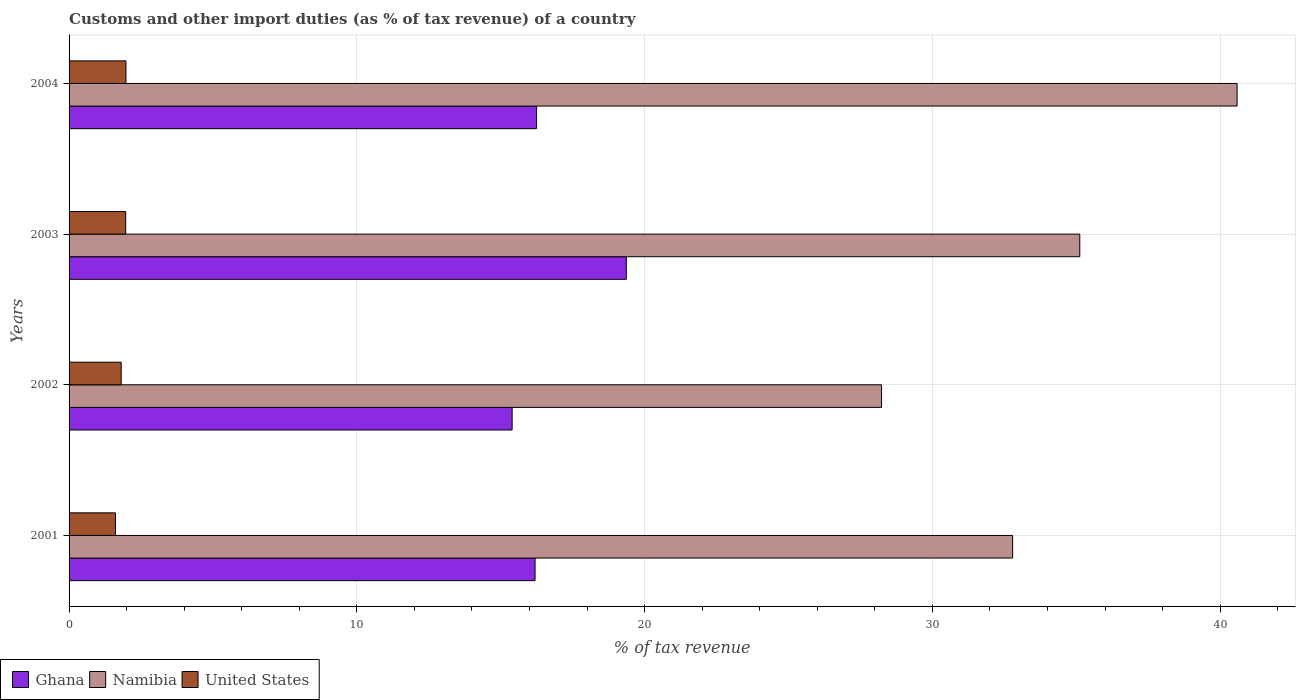How many groups of bars are there?
Provide a succinct answer. 4. Are the number of bars on each tick of the Y-axis equal?
Keep it short and to the point. Yes. How many bars are there on the 4th tick from the top?
Your answer should be very brief. 3. How many bars are there on the 1st tick from the bottom?
Your response must be concise. 3. What is the label of the 2nd group of bars from the top?
Offer a terse response. 2003. In how many cases, is the number of bars for a given year not equal to the number of legend labels?
Your response must be concise. 0. What is the percentage of tax revenue from customs in Ghana in 2004?
Provide a short and direct response. 16.25. Across all years, what is the maximum percentage of tax revenue from customs in Ghana?
Keep it short and to the point. 19.36. Across all years, what is the minimum percentage of tax revenue from customs in Ghana?
Provide a succinct answer. 15.4. In which year was the percentage of tax revenue from customs in United States minimum?
Make the answer very short. 2001. What is the total percentage of tax revenue from customs in Ghana in the graph?
Provide a short and direct response. 67.2. What is the difference between the percentage of tax revenue from customs in Namibia in 2001 and that in 2002?
Give a very brief answer. 4.55. What is the difference between the percentage of tax revenue from customs in United States in 2003 and the percentage of tax revenue from customs in Namibia in 2002?
Give a very brief answer. -26.27. What is the average percentage of tax revenue from customs in Namibia per year?
Ensure brevity in your answer.  34.18. In the year 2003, what is the difference between the percentage of tax revenue from customs in United States and percentage of tax revenue from customs in Ghana?
Provide a succinct answer. -17.4. What is the ratio of the percentage of tax revenue from customs in United States in 2001 to that in 2003?
Offer a very short reply. 0.82. Is the difference between the percentage of tax revenue from customs in United States in 2002 and 2003 greater than the difference between the percentage of tax revenue from customs in Ghana in 2002 and 2003?
Your response must be concise. Yes. What is the difference between the highest and the second highest percentage of tax revenue from customs in Namibia?
Provide a succinct answer. 5.47. What is the difference between the highest and the lowest percentage of tax revenue from customs in United States?
Provide a succinct answer. 0.36. In how many years, is the percentage of tax revenue from customs in Ghana greater than the average percentage of tax revenue from customs in Ghana taken over all years?
Provide a succinct answer. 1. Is the sum of the percentage of tax revenue from customs in Namibia in 2002 and 2004 greater than the maximum percentage of tax revenue from customs in Ghana across all years?
Offer a terse response. Yes. What does the 2nd bar from the top in 2002 represents?
Offer a very short reply. Namibia. What does the 2nd bar from the bottom in 2004 represents?
Make the answer very short. Namibia. Is it the case that in every year, the sum of the percentage of tax revenue from customs in United States and percentage of tax revenue from customs in Ghana is greater than the percentage of tax revenue from customs in Namibia?
Give a very brief answer. No. How many bars are there?
Provide a succinct answer. 12. Are all the bars in the graph horizontal?
Keep it short and to the point. Yes. What is the difference between two consecutive major ticks on the X-axis?
Your answer should be compact. 10. Does the graph contain grids?
Give a very brief answer. Yes. What is the title of the graph?
Offer a very short reply. Customs and other import duties (as % of tax revenue) of a country. Does "Liechtenstein" appear as one of the legend labels in the graph?
Provide a short and direct response. No. What is the label or title of the X-axis?
Ensure brevity in your answer.  % of tax revenue. What is the label or title of the Y-axis?
Offer a terse response. Years. What is the % of tax revenue of Ghana in 2001?
Provide a short and direct response. 16.19. What is the % of tax revenue of Namibia in 2001?
Keep it short and to the point. 32.79. What is the % of tax revenue of United States in 2001?
Make the answer very short. 1.61. What is the % of tax revenue in Ghana in 2002?
Offer a very short reply. 15.4. What is the % of tax revenue in Namibia in 2002?
Your answer should be very brief. 28.23. What is the % of tax revenue in United States in 2002?
Provide a short and direct response. 1.81. What is the % of tax revenue of Ghana in 2003?
Make the answer very short. 19.36. What is the % of tax revenue of Namibia in 2003?
Provide a succinct answer. 35.12. What is the % of tax revenue in United States in 2003?
Your response must be concise. 1.97. What is the % of tax revenue in Ghana in 2004?
Provide a succinct answer. 16.25. What is the % of tax revenue of Namibia in 2004?
Your answer should be very brief. 40.59. What is the % of tax revenue in United States in 2004?
Keep it short and to the point. 1.98. Across all years, what is the maximum % of tax revenue of Ghana?
Provide a short and direct response. 19.36. Across all years, what is the maximum % of tax revenue in Namibia?
Give a very brief answer. 40.59. Across all years, what is the maximum % of tax revenue of United States?
Offer a very short reply. 1.98. Across all years, what is the minimum % of tax revenue of Ghana?
Your answer should be very brief. 15.4. Across all years, what is the minimum % of tax revenue of Namibia?
Ensure brevity in your answer.  28.23. Across all years, what is the minimum % of tax revenue of United States?
Give a very brief answer. 1.61. What is the total % of tax revenue in Ghana in the graph?
Keep it short and to the point. 67.2. What is the total % of tax revenue in Namibia in the graph?
Your answer should be very brief. 136.73. What is the total % of tax revenue of United States in the graph?
Keep it short and to the point. 7.37. What is the difference between the % of tax revenue of Ghana in 2001 and that in 2002?
Give a very brief answer. 0.8. What is the difference between the % of tax revenue of Namibia in 2001 and that in 2002?
Provide a short and direct response. 4.55. What is the difference between the % of tax revenue in United States in 2001 and that in 2002?
Offer a very short reply. -0.2. What is the difference between the % of tax revenue in Ghana in 2001 and that in 2003?
Keep it short and to the point. -3.17. What is the difference between the % of tax revenue of Namibia in 2001 and that in 2003?
Provide a succinct answer. -2.33. What is the difference between the % of tax revenue in United States in 2001 and that in 2003?
Make the answer very short. -0.35. What is the difference between the % of tax revenue in Ghana in 2001 and that in 2004?
Your response must be concise. -0.05. What is the difference between the % of tax revenue of Namibia in 2001 and that in 2004?
Ensure brevity in your answer.  -7.8. What is the difference between the % of tax revenue of United States in 2001 and that in 2004?
Offer a very short reply. -0.36. What is the difference between the % of tax revenue in Ghana in 2002 and that in 2003?
Your response must be concise. -3.97. What is the difference between the % of tax revenue of Namibia in 2002 and that in 2003?
Ensure brevity in your answer.  -6.89. What is the difference between the % of tax revenue of United States in 2002 and that in 2003?
Provide a short and direct response. -0.16. What is the difference between the % of tax revenue of Ghana in 2002 and that in 2004?
Keep it short and to the point. -0.85. What is the difference between the % of tax revenue of Namibia in 2002 and that in 2004?
Keep it short and to the point. -12.35. What is the difference between the % of tax revenue of United States in 2002 and that in 2004?
Your answer should be very brief. -0.17. What is the difference between the % of tax revenue in Ghana in 2003 and that in 2004?
Provide a short and direct response. 3.12. What is the difference between the % of tax revenue of Namibia in 2003 and that in 2004?
Offer a very short reply. -5.47. What is the difference between the % of tax revenue of United States in 2003 and that in 2004?
Your response must be concise. -0.01. What is the difference between the % of tax revenue of Ghana in 2001 and the % of tax revenue of Namibia in 2002?
Ensure brevity in your answer.  -12.04. What is the difference between the % of tax revenue of Ghana in 2001 and the % of tax revenue of United States in 2002?
Ensure brevity in your answer.  14.38. What is the difference between the % of tax revenue in Namibia in 2001 and the % of tax revenue in United States in 2002?
Offer a very short reply. 30.98. What is the difference between the % of tax revenue of Ghana in 2001 and the % of tax revenue of Namibia in 2003?
Make the answer very short. -18.93. What is the difference between the % of tax revenue of Ghana in 2001 and the % of tax revenue of United States in 2003?
Your response must be concise. 14.23. What is the difference between the % of tax revenue in Namibia in 2001 and the % of tax revenue in United States in 2003?
Keep it short and to the point. 30.82. What is the difference between the % of tax revenue of Ghana in 2001 and the % of tax revenue of Namibia in 2004?
Provide a succinct answer. -24.4. What is the difference between the % of tax revenue in Ghana in 2001 and the % of tax revenue in United States in 2004?
Offer a very short reply. 14.22. What is the difference between the % of tax revenue in Namibia in 2001 and the % of tax revenue in United States in 2004?
Keep it short and to the point. 30.81. What is the difference between the % of tax revenue of Ghana in 2002 and the % of tax revenue of Namibia in 2003?
Offer a terse response. -19.73. What is the difference between the % of tax revenue in Ghana in 2002 and the % of tax revenue in United States in 2003?
Offer a very short reply. 13.43. What is the difference between the % of tax revenue in Namibia in 2002 and the % of tax revenue in United States in 2003?
Your response must be concise. 26.27. What is the difference between the % of tax revenue of Ghana in 2002 and the % of tax revenue of Namibia in 2004?
Your response must be concise. -25.19. What is the difference between the % of tax revenue of Ghana in 2002 and the % of tax revenue of United States in 2004?
Give a very brief answer. 13.42. What is the difference between the % of tax revenue of Namibia in 2002 and the % of tax revenue of United States in 2004?
Provide a short and direct response. 26.26. What is the difference between the % of tax revenue of Ghana in 2003 and the % of tax revenue of Namibia in 2004?
Your answer should be very brief. -21.22. What is the difference between the % of tax revenue of Ghana in 2003 and the % of tax revenue of United States in 2004?
Ensure brevity in your answer.  17.39. What is the difference between the % of tax revenue of Namibia in 2003 and the % of tax revenue of United States in 2004?
Keep it short and to the point. 33.14. What is the average % of tax revenue of Ghana per year?
Your response must be concise. 16.8. What is the average % of tax revenue of Namibia per year?
Offer a terse response. 34.18. What is the average % of tax revenue in United States per year?
Provide a succinct answer. 1.84. In the year 2001, what is the difference between the % of tax revenue of Ghana and % of tax revenue of Namibia?
Your answer should be very brief. -16.6. In the year 2001, what is the difference between the % of tax revenue of Ghana and % of tax revenue of United States?
Your answer should be very brief. 14.58. In the year 2001, what is the difference between the % of tax revenue in Namibia and % of tax revenue in United States?
Ensure brevity in your answer.  31.18. In the year 2002, what is the difference between the % of tax revenue in Ghana and % of tax revenue in Namibia?
Keep it short and to the point. -12.84. In the year 2002, what is the difference between the % of tax revenue in Ghana and % of tax revenue in United States?
Your response must be concise. 13.59. In the year 2002, what is the difference between the % of tax revenue of Namibia and % of tax revenue of United States?
Ensure brevity in your answer.  26.42. In the year 2003, what is the difference between the % of tax revenue in Ghana and % of tax revenue in Namibia?
Keep it short and to the point. -15.76. In the year 2003, what is the difference between the % of tax revenue in Ghana and % of tax revenue in United States?
Your answer should be compact. 17.4. In the year 2003, what is the difference between the % of tax revenue of Namibia and % of tax revenue of United States?
Make the answer very short. 33.15. In the year 2004, what is the difference between the % of tax revenue of Ghana and % of tax revenue of Namibia?
Your answer should be very brief. -24.34. In the year 2004, what is the difference between the % of tax revenue in Ghana and % of tax revenue in United States?
Your answer should be very brief. 14.27. In the year 2004, what is the difference between the % of tax revenue in Namibia and % of tax revenue in United States?
Ensure brevity in your answer.  38.61. What is the ratio of the % of tax revenue of Ghana in 2001 to that in 2002?
Your response must be concise. 1.05. What is the ratio of the % of tax revenue of Namibia in 2001 to that in 2002?
Keep it short and to the point. 1.16. What is the ratio of the % of tax revenue in United States in 2001 to that in 2002?
Your response must be concise. 0.89. What is the ratio of the % of tax revenue of Ghana in 2001 to that in 2003?
Offer a terse response. 0.84. What is the ratio of the % of tax revenue of Namibia in 2001 to that in 2003?
Your answer should be compact. 0.93. What is the ratio of the % of tax revenue in United States in 2001 to that in 2003?
Keep it short and to the point. 0.82. What is the ratio of the % of tax revenue in Namibia in 2001 to that in 2004?
Ensure brevity in your answer.  0.81. What is the ratio of the % of tax revenue in United States in 2001 to that in 2004?
Offer a terse response. 0.82. What is the ratio of the % of tax revenue in Ghana in 2002 to that in 2003?
Offer a very short reply. 0.8. What is the ratio of the % of tax revenue of Namibia in 2002 to that in 2003?
Ensure brevity in your answer.  0.8. What is the ratio of the % of tax revenue in United States in 2002 to that in 2003?
Provide a short and direct response. 0.92. What is the ratio of the % of tax revenue of Ghana in 2002 to that in 2004?
Give a very brief answer. 0.95. What is the ratio of the % of tax revenue in Namibia in 2002 to that in 2004?
Your answer should be very brief. 0.7. What is the ratio of the % of tax revenue in United States in 2002 to that in 2004?
Your response must be concise. 0.92. What is the ratio of the % of tax revenue in Ghana in 2003 to that in 2004?
Make the answer very short. 1.19. What is the ratio of the % of tax revenue of Namibia in 2003 to that in 2004?
Ensure brevity in your answer.  0.87. What is the ratio of the % of tax revenue in United States in 2003 to that in 2004?
Give a very brief answer. 1. What is the difference between the highest and the second highest % of tax revenue in Ghana?
Offer a terse response. 3.12. What is the difference between the highest and the second highest % of tax revenue in Namibia?
Provide a succinct answer. 5.47. What is the difference between the highest and the second highest % of tax revenue in United States?
Ensure brevity in your answer.  0.01. What is the difference between the highest and the lowest % of tax revenue of Ghana?
Ensure brevity in your answer.  3.97. What is the difference between the highest and the lowest % of tax revenue in Namibia?
Provide a short and direct response. 12.35. What is the difference between the highest and the lowest % of tax revenue of United States?
Give a very brief answer. 0.36. 